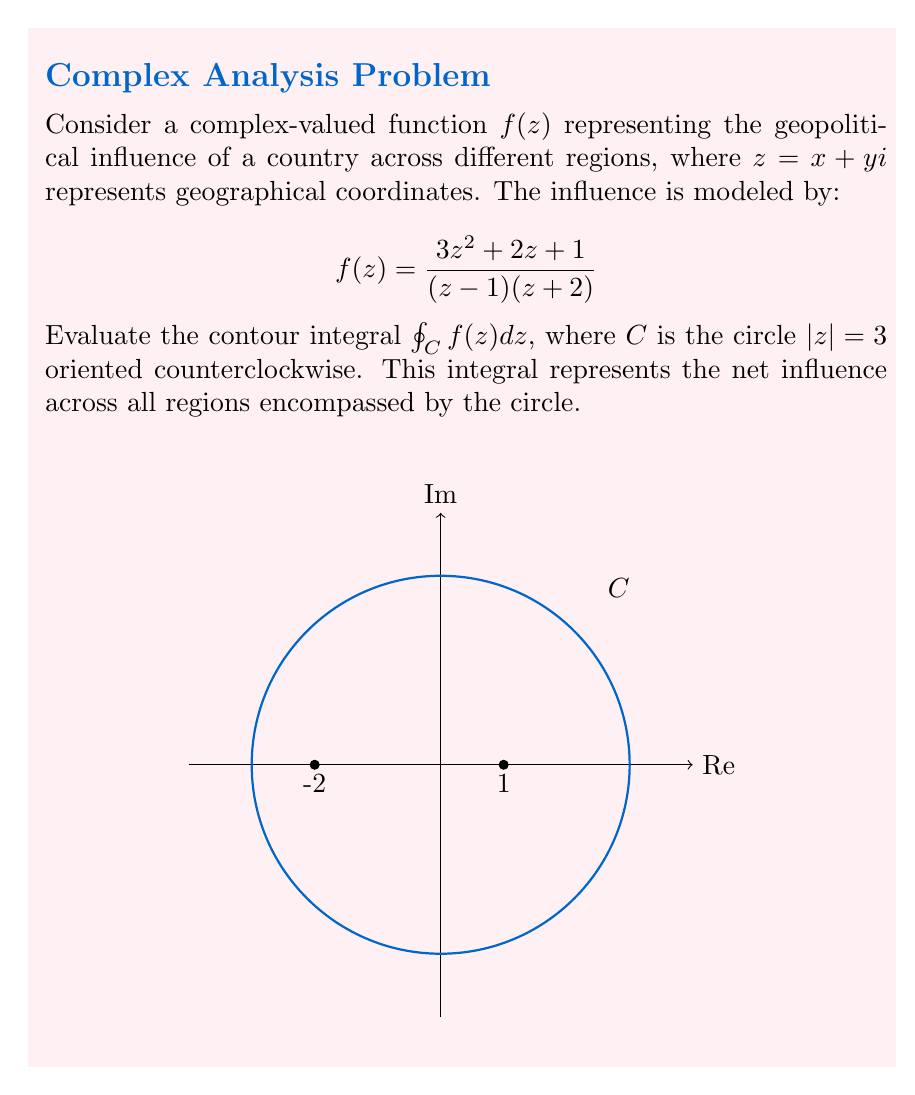Help me with this question. To evaluate this contour integral, we'll use the Residue Theorem:

$$\oint_C f(z) dz = 2\pi i \sum_{k=1}^n \text{Res}(f, z_k)$$

where $z_k$ are the poles of $f(z)$ inside $C$.

Step 1: Identify the poles
The poles are at $z = 1$ and $z = -2$. Only $z = 1$ is inside $C$.

Step 2: Calculate the residue at $z = 1$
$$\text{Res}(f, 1) = \lim_{z \to 1} (z-1)f(z) = \lim_{z \to 1} \frac{3z^2 + 2z + 1}{z+2} = \frac{3(1)^2 + 2(1) + 1}{1+2} = 2$$

Step 3: Apply the Residue Theorem
$$\oint_C f(z) dz = 2\pi i \cdot \text{Res}(f, 1) = 2\pi i \cdot 2 = 4\pi i$$

This result represents the net geopolitical influence across all regions encompassed by the circle $|z| = 3$.
Answer: $4\pi i$ 